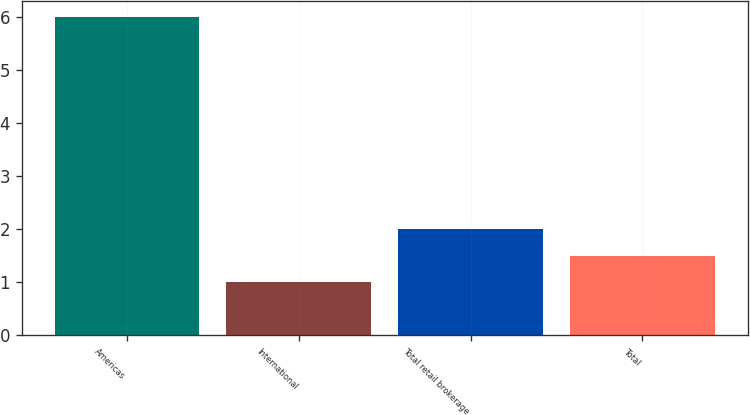Convert chart to OTSL. <chart><loc_0><loc_0><loc_500><loc_500><bar_chart><fcel>Americas<fcel>International<fcel>Total retail brokerage<fcel>Total<nl><fcel>6<fcel>1<fcel>2<fcel>1.5<nl></chart> 